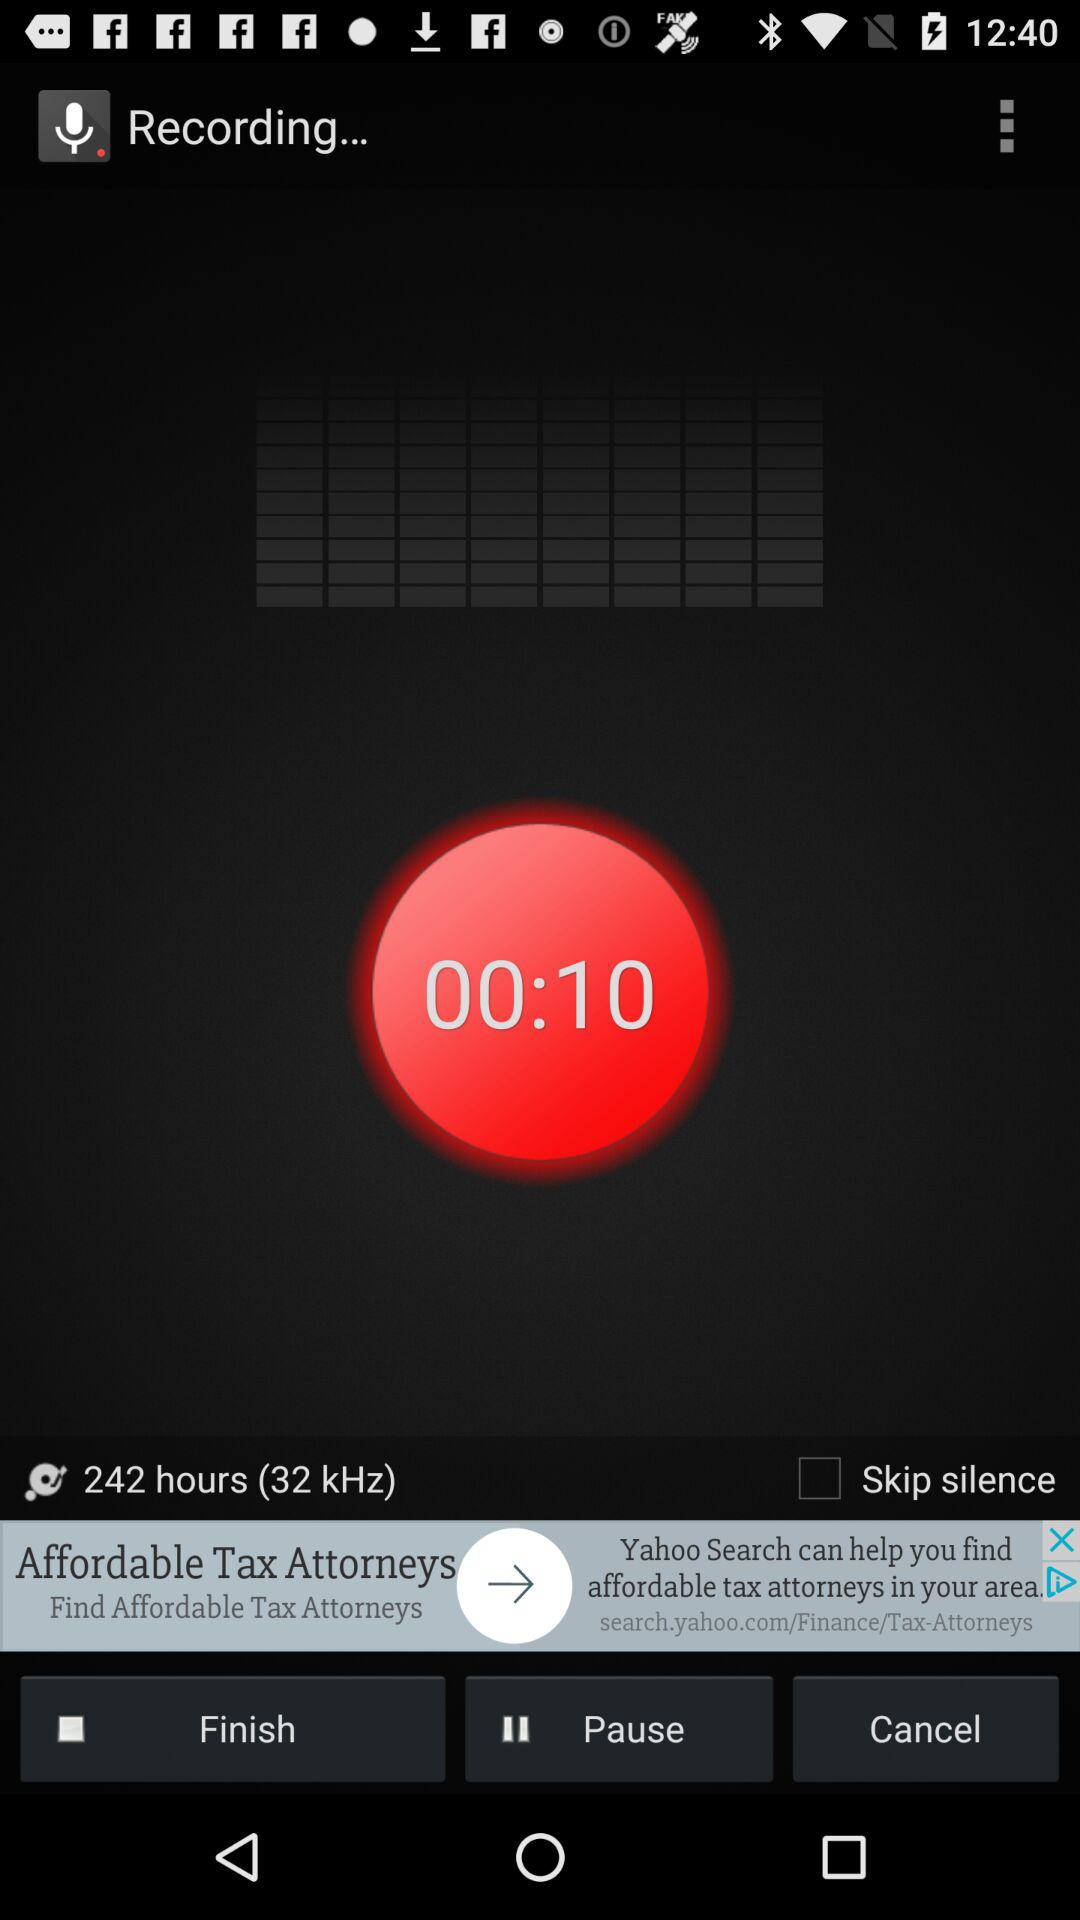What is the time duration? The time durations are 10 seconds and 242 hours. 